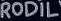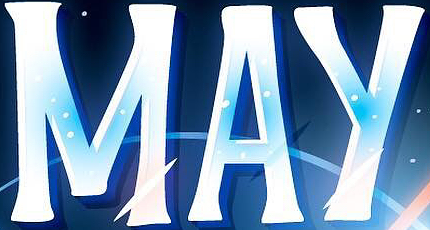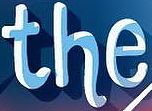What words can you see in these images in sequence, separated by a semicolon? RODIL; MAY; the 